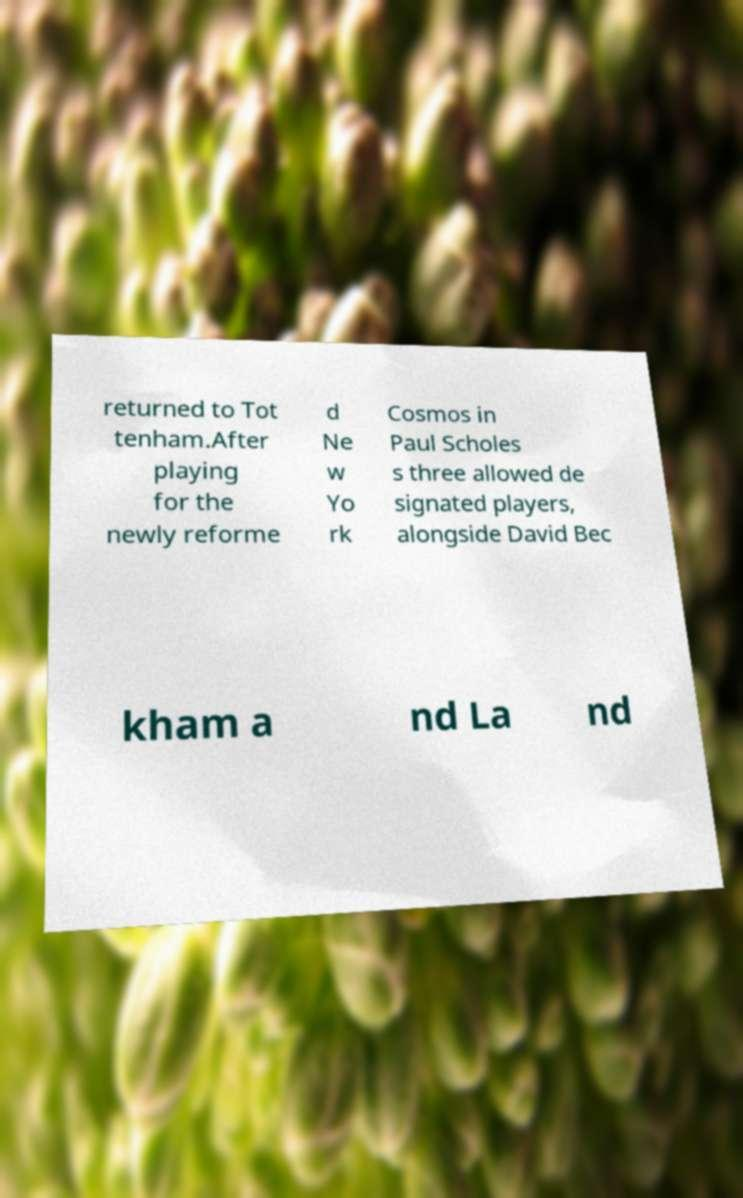For documentation purposes, I need the text within this image transcribed. Could you provide that? returned to Tot tenham.After playing for the newly reforme d Ne w Yo rk Cosmos in Paul Scholes s three allowed de signated players, alongside David Bec kham a nd La nd 